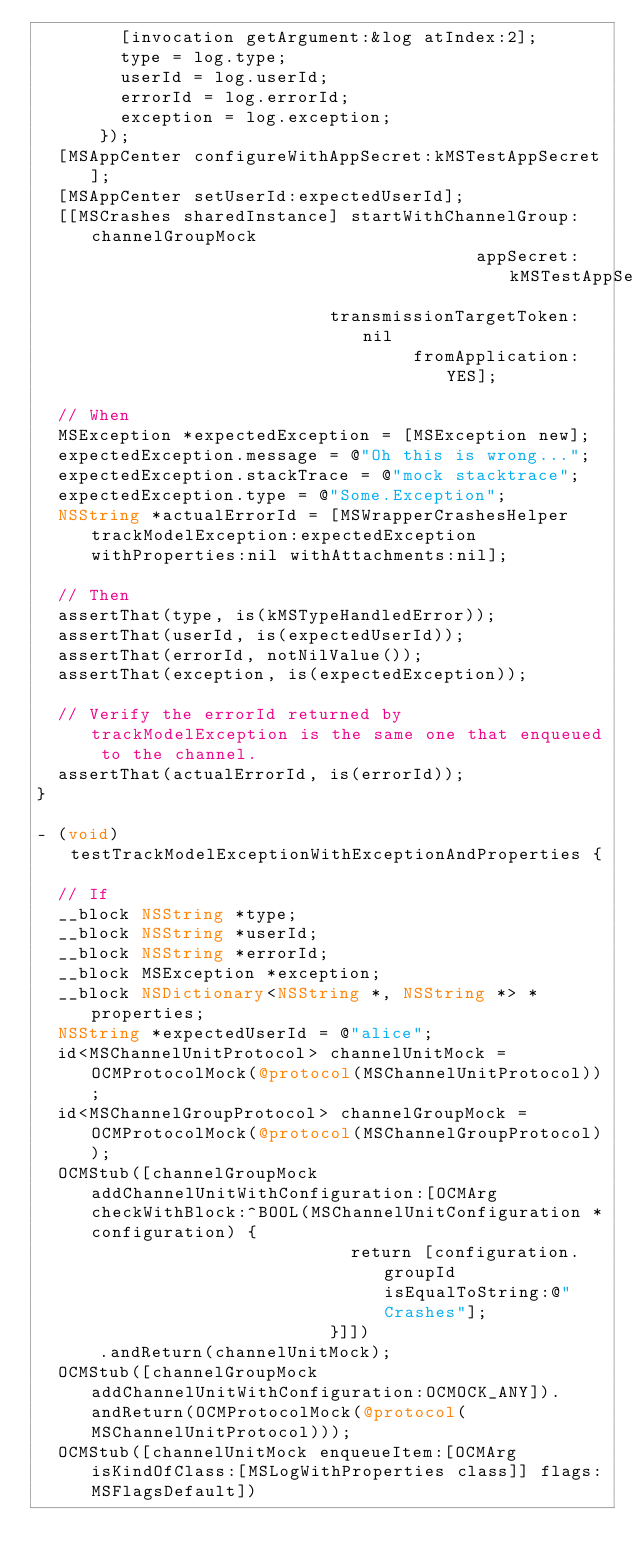<code> <loc_0><loc_0><loc_500><loc_500><_ObjectiveC_>        [invocation getArgument:&log atIndex:2];
        type = log.type;
        userId = log.userId;
        errorId = log.errorId;
        exception = log.exception;
      });
  [MSAppCenter configureWithAppSecret:kMSTestAppSecret];
  [MSAppCenter setUserId:expectedUserId];
  [[MSCrashes sharedInstance] startWithChannelGroup:channelGroupMock
                                          appSecret:kMSTestAppSecret
                            transmissionTargetToken:nil
                                    fromApplication:YES];

  // When
  MSException *expectedException = [MSException new];
  expectedException.message = @"Oh this is wrong...";
  expectedException.stackTrace = @"mock stacktrace";
  expectedException.type = @"Some.Exception";
  NSString *actualErrorId = [MSWrapperCrashesHelper trackModelException:expectedException withProperties:nil withAttachments:nil];

  // Then
  assertThat(type, is(kMSTypeHandledError));
  assertThat(userId, is(expectedUserId));
  assertThat(errorId, notNilValue());
  assertThat(exception, is(expectedException));

  // Verify the errorId returned by trackModelException is the same one that enqueued to the channel.
  assertThat(actualErrorId, is(errorId));
}

- (void)testTrackModelExceptionWithExceptionAndProperties {

  // If
  __block NSString *type;
  __block NSString *userId;
  __block NSString *errorId;
  __block MSException *exception;
  __block NSDictionary<NSString *, NSString *> *properties;
  NSString *expectedUserId = @"alice";
  id<MSChannelUnitProtocol> channelUnitMock = OCMProtocolMock(@protocol(MSChannelUnitProtocol));
  id<MSChannelGroupProtocol> channelGroupMock = OCMProtocolMock(@protocol(MSChannelGroupProtocol));
  OCMStub([channelGroupMock addChannelUnitWithConfiguration:[OCMArg checkWithBlock:^BOOL(MSChannelUnitConfiguration *configuration) {
                              return [configuration.groupId isEqualToString:@"Crashes"];
                            }]])
      .andReturn(channelUnitMock);
  OCMStub([channelGroupMock addChannelUnitWithConfiguration:OCMOCK_ANY]).andReturn(OCMProtocolMock(@protocol(MSChannelUnitProtocol)));
  OCMStub([channelUnitMock enqueueItem:[OCMArg isKindOfClass:[MSLogWithProperties class]] flags:MSFlagsDefault])</code> 